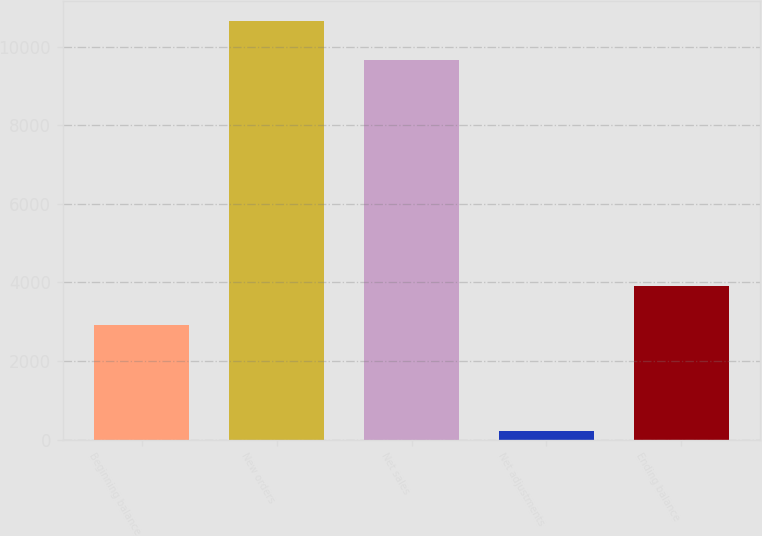Convert chart. <chart><loc_0><loc_0><loc_500><loc_500><bar_chart><fcel>Beginning balance<fcel>New orders<fcel>Net sales<fcel>Net adjustments<fcel>Ending balance<nl><fcel>2917<fcel>10647.4<fcel>9659<fcel>220<fcel>3905.4<nl></chart> 